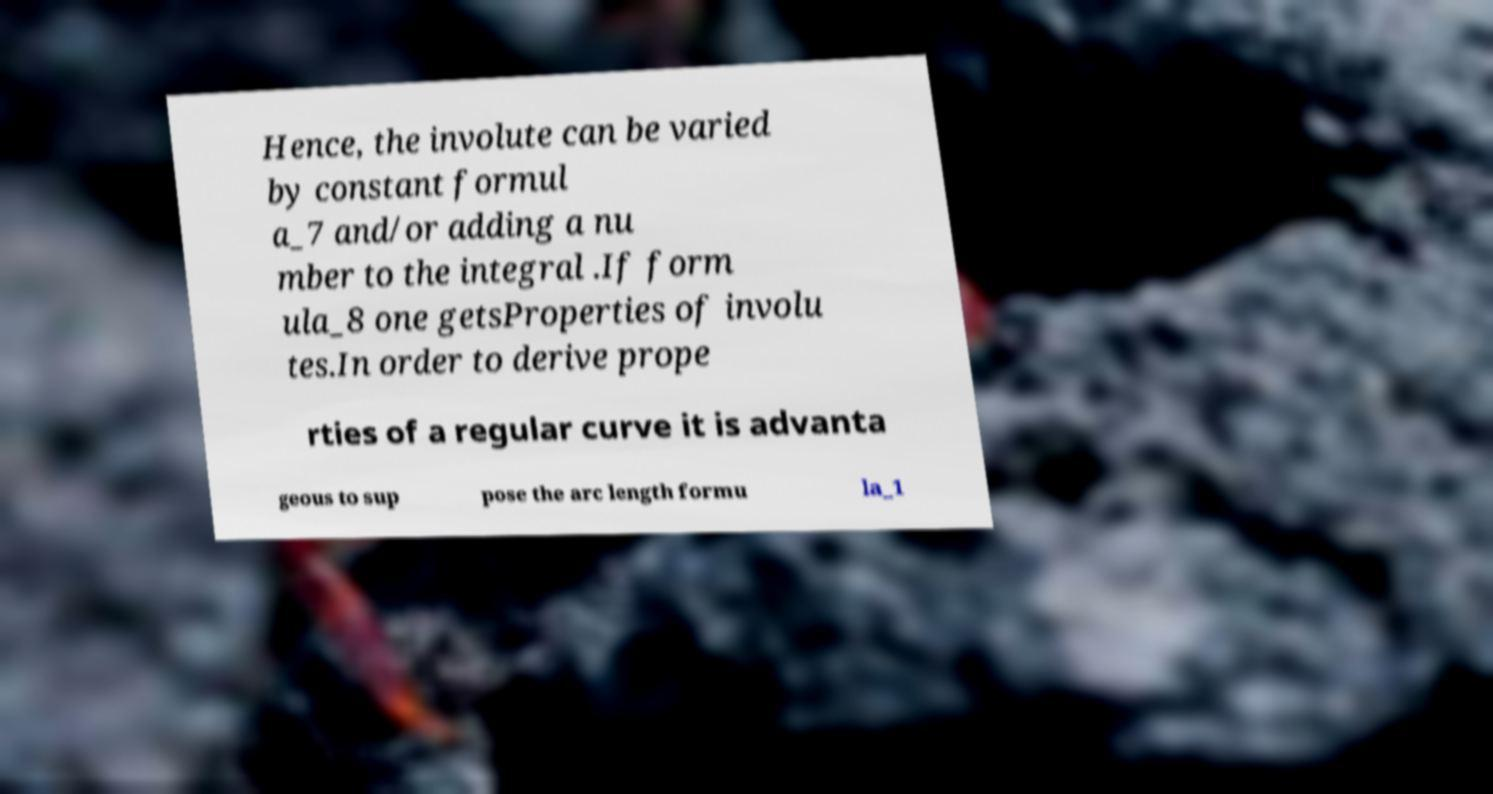Please read and relay the text visible in this image. What does it say? Hence, the involute can be varied by constant formul a_7 and/or adding a nu mber to the integral .If form ula_8 one getsProperties of involu tes.In order to derive prope rties of a regular curve it is advanta geous to sup pose the arc length formu la_1 